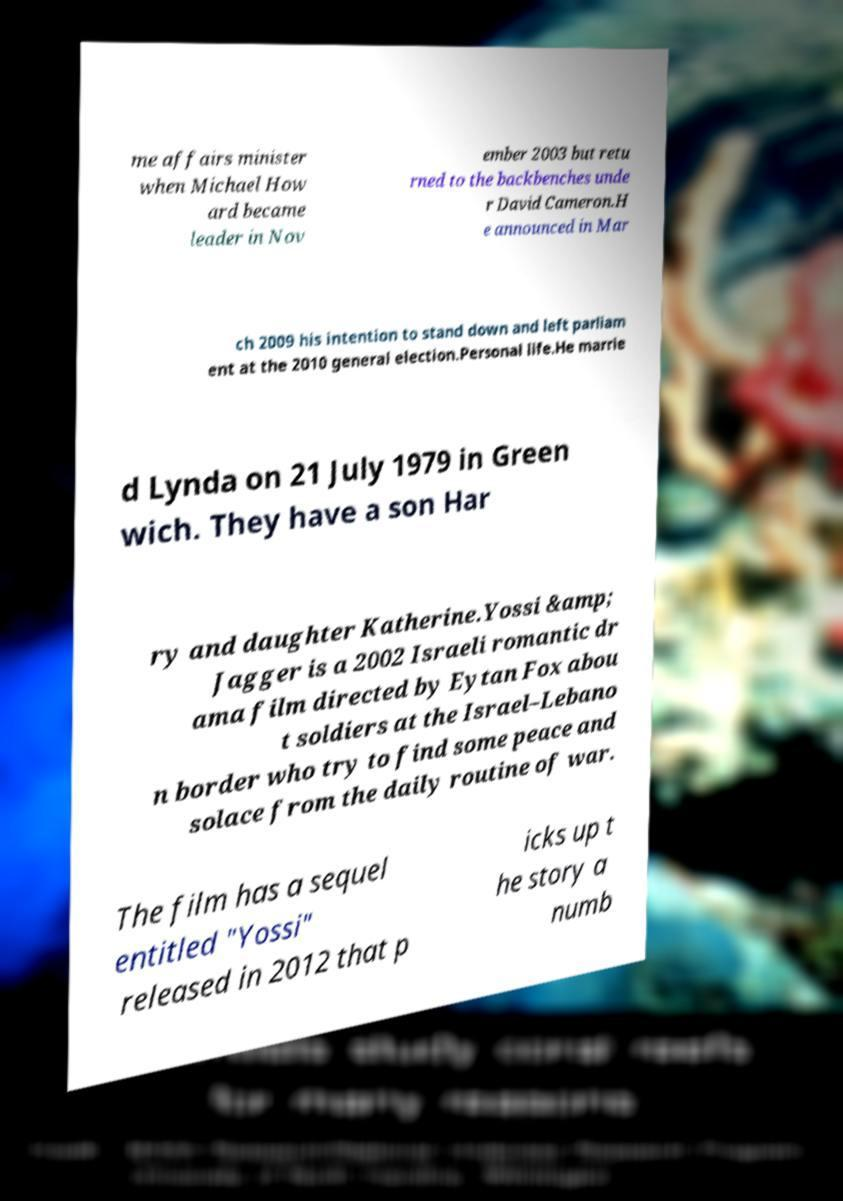There's text embedded in this image that I need extracted. Can you transcribe it verbatim? me affairs minister when Michael How ard became leader in Nov ember 2003 but retu rned to the backbenches unde r David Cameron.H e announced in Mar ch 2009 his intention to stand down and left parliam ent at the 2010 general election.Personal life.He marrie d Lynda on 21 July 1979 in Green wich. They have a son Har ry and daughter Katherine.Yossi &amp; Jagger is a 2002 Israeli romantic dr ama film directed by Eytan Fox abou t soldiers at the Israel–Lebano n border who try to find some peace and solace from the daily routine of war. The film has a sequel entitled "Yossi" released in 2012 that p icks up t he story a numb 